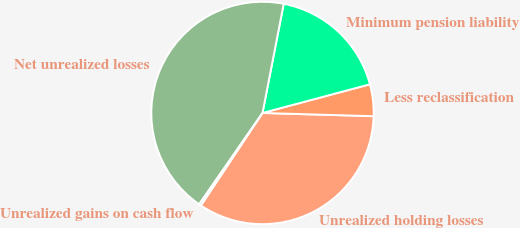<chart> <loc_0><loc_0><loc_500><loc_500><pie_chart><fcel>Unrealized holding losses<fcel>Less reclassification<fcel>Minimum pension liability<fcel>Net unrealized losses<fcel>Unrealized gains on cash flow<nl><fcel>33.89%<fcel>4.61%<fcel>17.8%<fcel>43.4%<fcel>0.3%<nl></chart> 